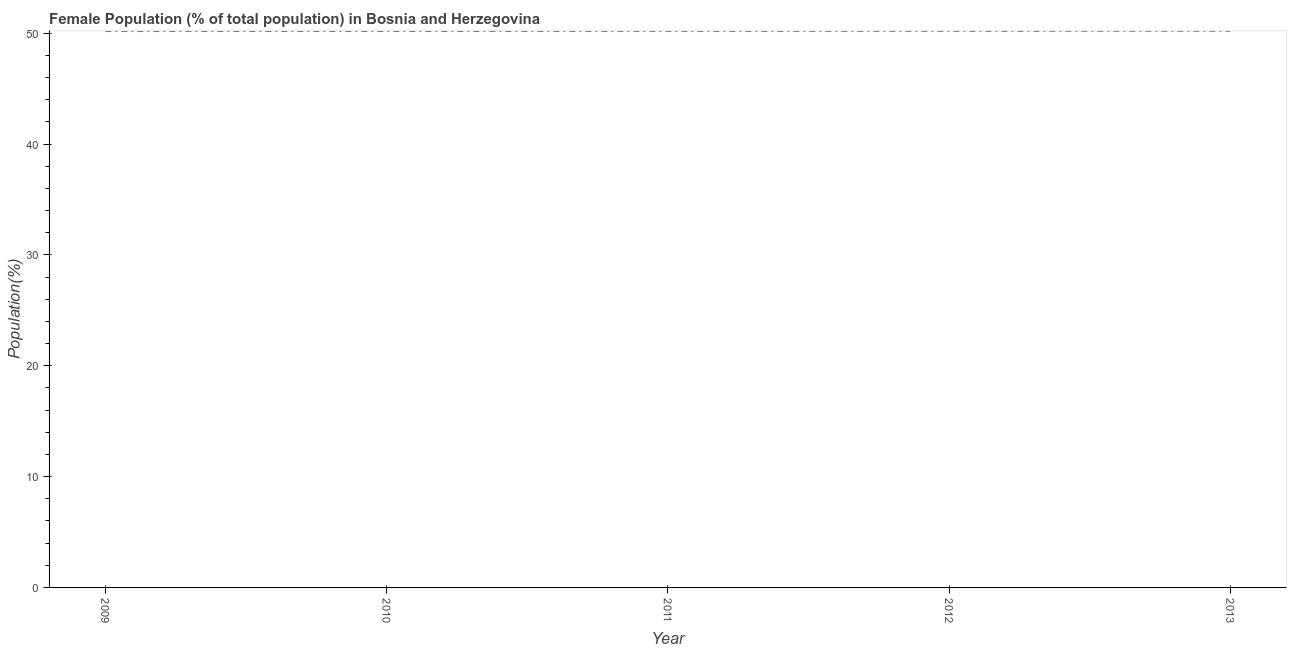What is the female population in 2009?
Keep it short and to the point. 50.2. Across all years, what is the maximum female population?
Ensure brevity in your answer.  50.22. Across all years, what is the minimum female population?
Ensure brevity in your answer.  50.2. In which year was the female population maximum?
Your response must be concise. 2013. In which year was the female population minimum?
Offer a very short reply. 2009. What is the sum of the female population?
Your answer should be compact. 251.06. What is the difference between the female population in 2012 and 2013?
Provide a short and direct response. -0. What is the average female population per year?
Offer a terse response. 50.21. What is the median female population?
Your answer should be very brief. 50.21. In how many years, is the female population greater than 22 %?
Offer a very short reply. 5. What is the ratio of the female population in 2012 to that in 2013?
Provide a short and direct response. 1. What is the difference between the highest and the second highest female population?
Keep it short and to the point. 0. What is the difference between the highest and the lowest female population?
Your response must be concise. 0.02. In how many years, is the female population greater than the average female population taken over all years?
Offer a very short reply. 2. How many lines are there?
Ensure brevity in your answer.  1. What is the title of the graph?
Offer a terse response. Female Population (% of total population) in Bosnia and Herzegovina. What is the label or title of the Y-axis?
Make the answer very short. Population(%). What is the Population(%) of 2009?
Keep it short and to the point. 50.2. What is the Population(%) in 2010?
Provide a succinct answer. 50.21. What is the Population(%) of 2011?
Make the answer very short. 50.21. What is the Population(%) in 2012?
Provide a succinct answer. 50.22. What is the Population(%) in 2013?
Offer a terse response. 50.22. What is the difference between the Population(%) in 2009 and 2010?
Make the answer very short. -0. What is the difference between the Population(%) in 2009 and 2011?
Offer a terse response. -0.01. What is the difference between the Population(%) in 2009 and 2012?
Ensure brevity in your answer.  -0.01. What is the difference between the Population(%) in 2009 and 2013?
Your answer should be compact. -0.02. What is the difference between the Population(%) in 2010 and 2011?
Ensure brevity in your answer.  -0. What is the difference between the Population(%) in 2010 and 2012?
Give a very brief answer. -0.01. What is the difference between the Population(%) in 2010 and 2013?
Keep it short and to the point. -0.01. What is the difference between the Population(%) in 2011 and 2012?
Your response must be concise. -0. What is the difference between the Population(%) in 2011 and 2013?
Give a very brief answer. -0.01. What is the difference between the Population(%) in 2012 and 2013?
Provide a short and direct response. -0. What is the ratio of the Population(%) in 2009 to that in 2011?
Provide a succinct answer. 1. What is the ratio of the Population(%) in 2009 to that in 2012?
Offer a terse response. 1. What is the ratio of the Population(%) in 2009 to that in 2013?
Offer a very short reply. 1. What is the ratio of the Population(%) in 2010 to that in 2012?
Offer a very short reply. 1. What is the ratio of the Population(%) in 2010 to that in 2013?
Your response must be concise. 1. What is the ratio of the Population(%) in 2011 to that in 2013?
Make the answer very short. 1. What is the ratio of the Population(%) in 2012 to that in 2013?
Give a very brief answer. 1. 